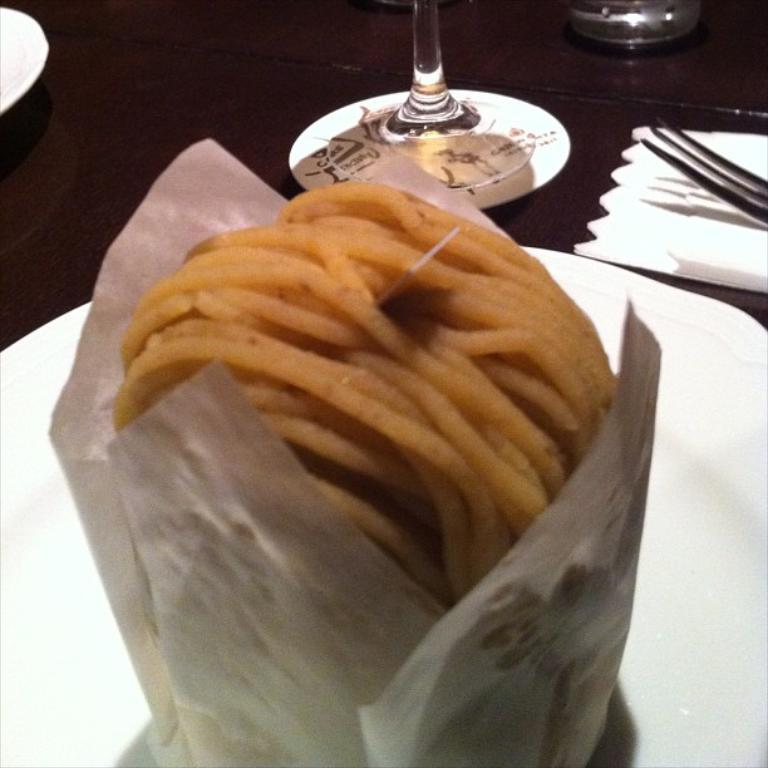What type of tableware can be seen in the image? There are glasses and a fork in the image. What else is present on the table in the image? There is a plate with a food item in the image. Where are the glasses, fork, and plate located in the image? They are placed on a table. What type of skin condition can be seen on the fork in the image? There is no skin condition present on the fork in the image, as it is a utensil and not a living organism. 